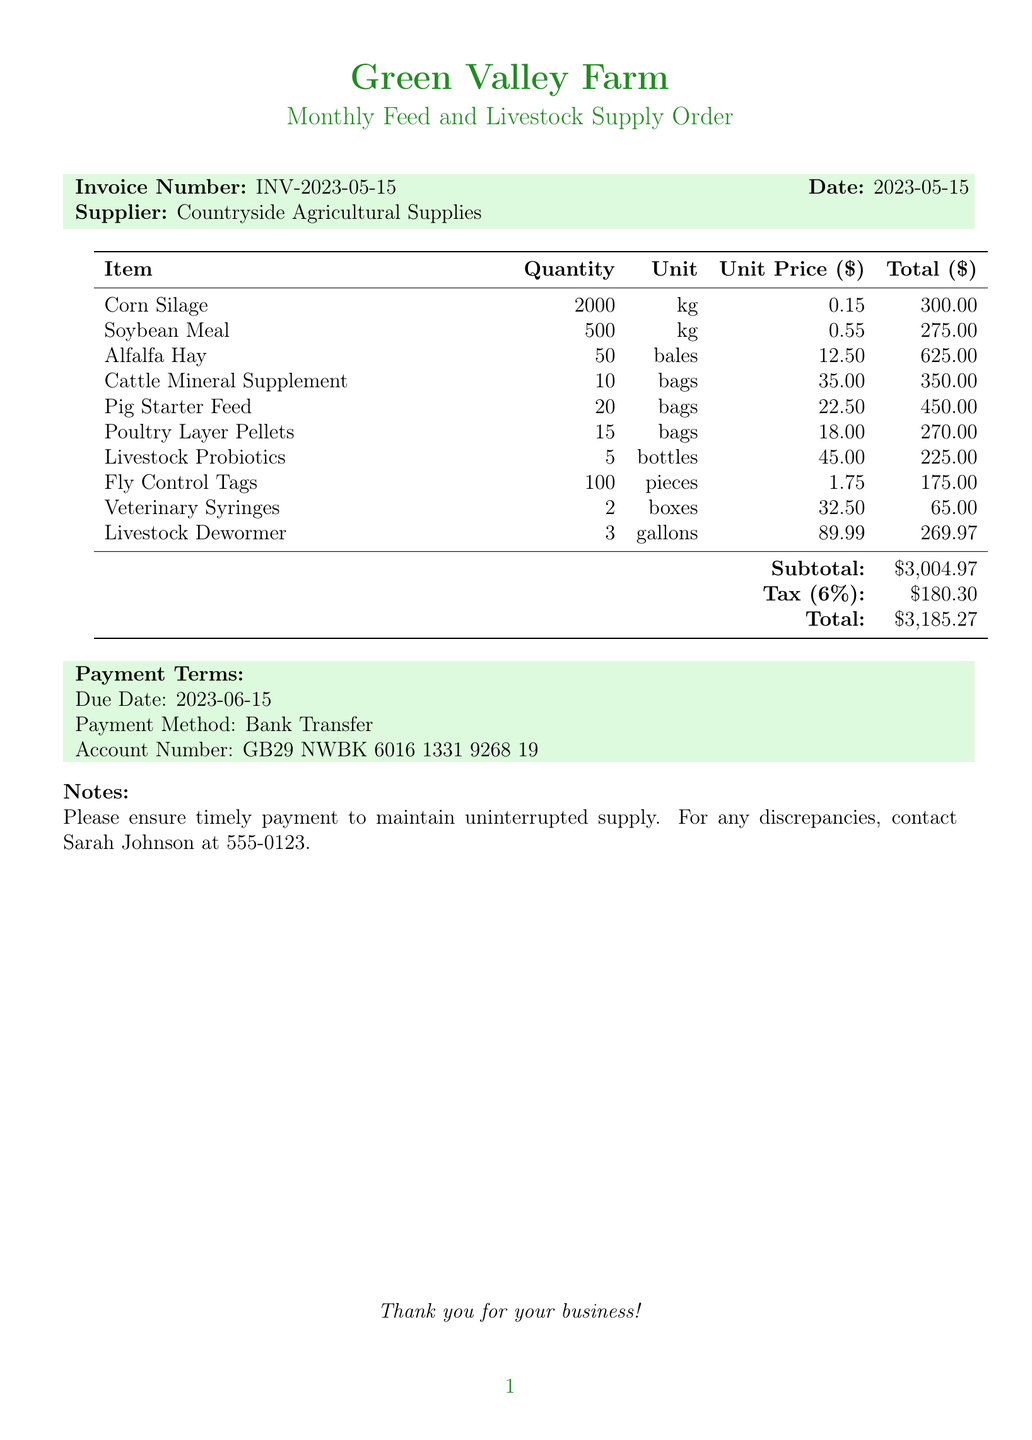What is the invoice number? The invoice number is displayed clearly on the document under the invoice details section.
Answer: INV-2023-05-15 What is the date of the invoice? The date of the invoice is noted right next to the invoice number.
Answer: 2023-05-15 Who is the supplier? The supplier's name is indicated in the invoice header section of the document.
Answer: Countryside Agricultural Supplies What is the total cost of Alfalfa Hay? The total cost can be found next to the item name Alfalfa Hay in the list of items.
Answer: 625.00 How many units of Pig Starter Feed were ordered? The quantity is listed under the Pig Starter Feed item in the itemized table.
Answer: 20 What is the subtotal amount before tax? The subtotal is summarized at the bottom of the item list before tax is applied.
Answer: 3004.97 What is the payment method? The payment method is described in the payment terms section of the document.
Answer: Bank Transfer What is the tax amount? The tax amount is shown in the totals section, reflecting the calculated tax for the invoice.
Answer: 180.30 When is the payment due date? The due date is specified in the payment terms section, indicating when payment must be made.
Answer: 2023-06-15 